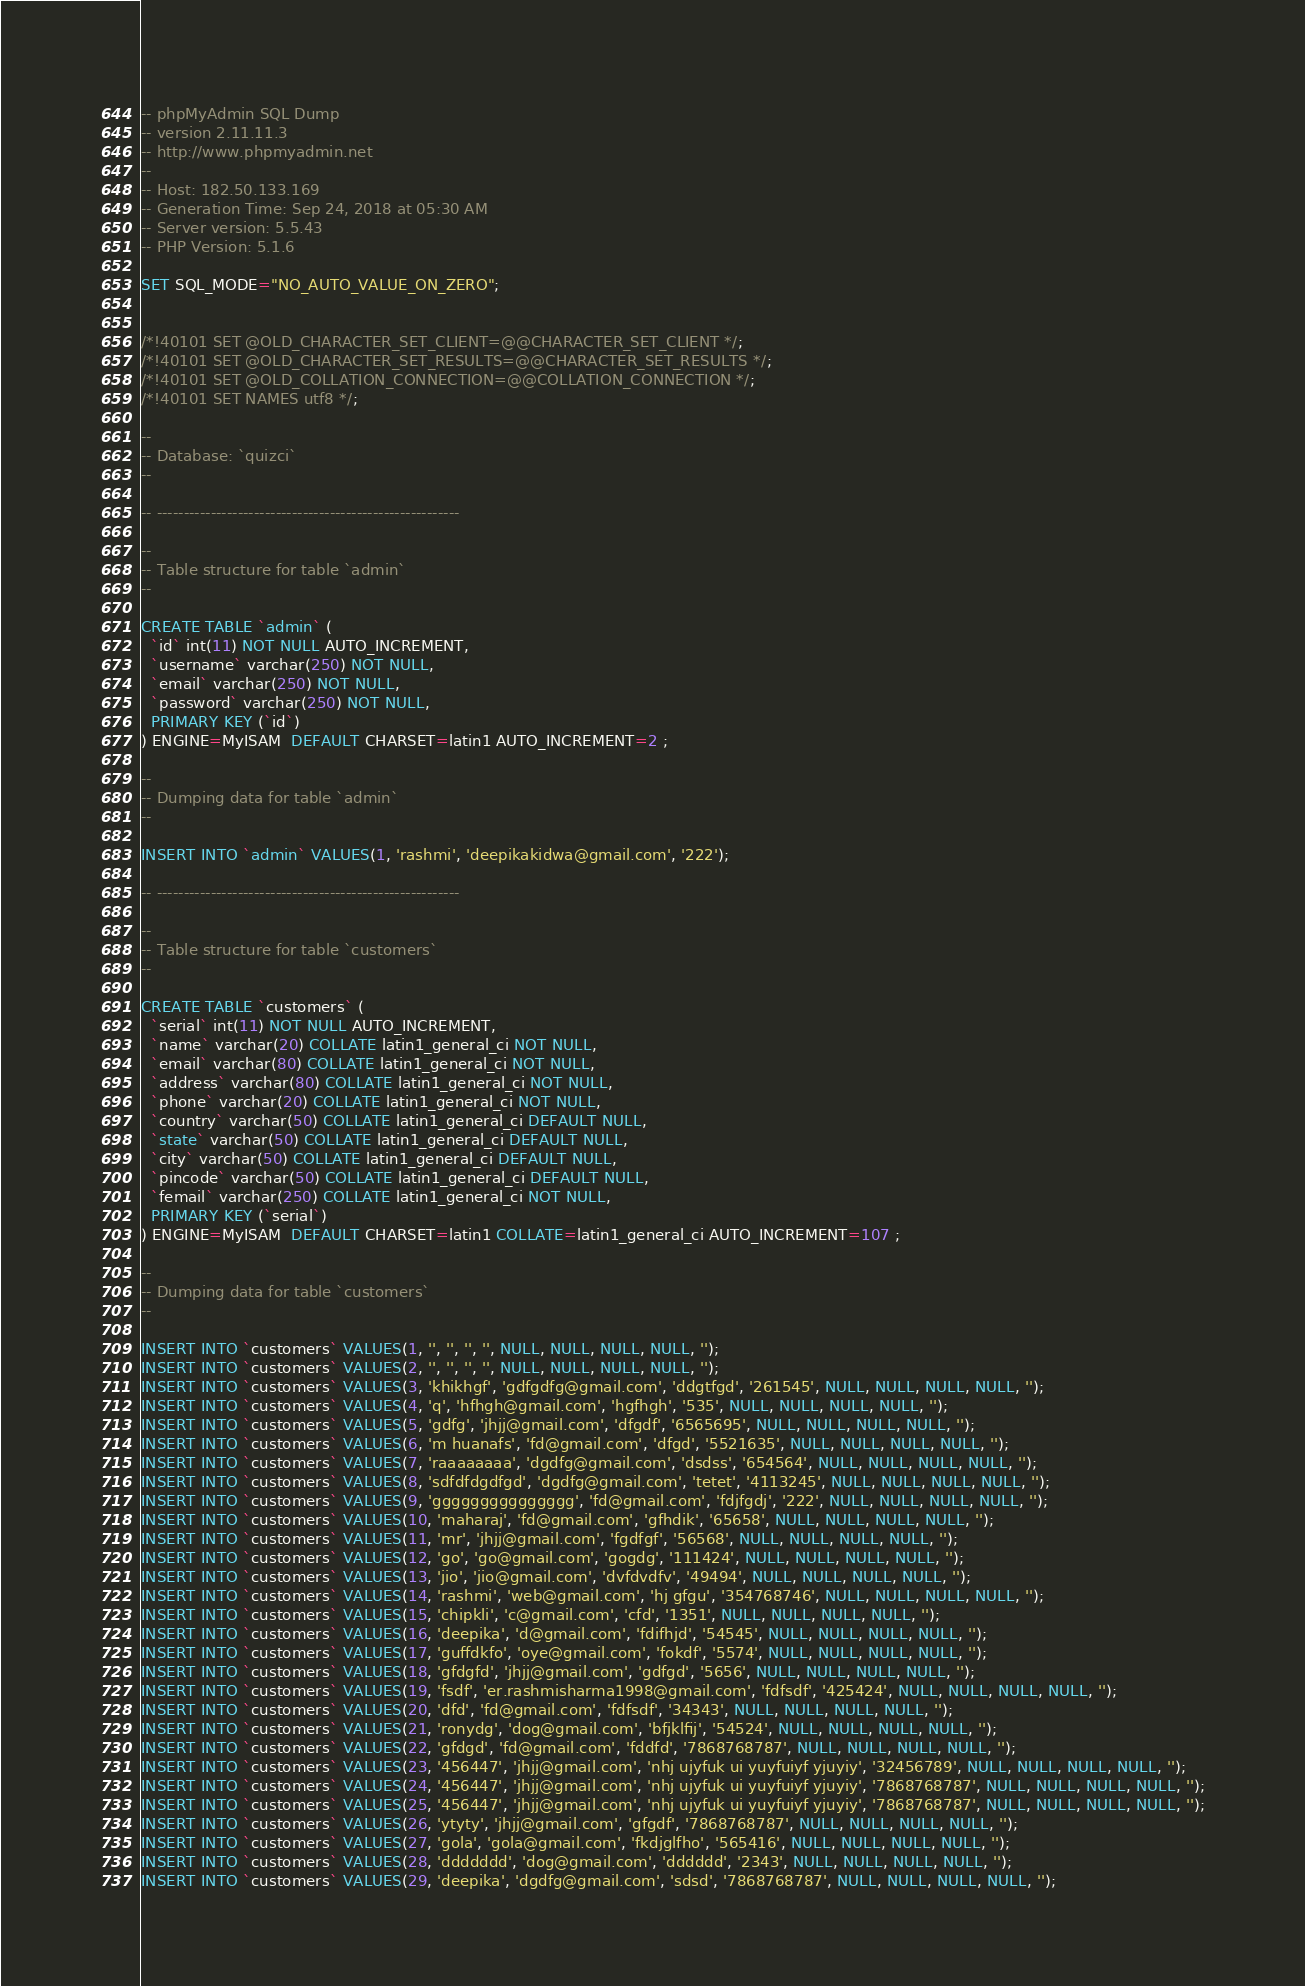Convert code to text. <code><loc_0><loc_0><loc_500><loc_500><_SQL_>-- phpMyAdmin SQL Dump
-- version 2.11.11.3
-- http://www.phpmyadmin.net
--
-- Host: 182.50.133.169
-- Generation Time: Sep 24, 2018 at 05:30 AM
-- Server version: 5.5.43
-- PHP Version: 5.1.6

SET SQL_MODE="NO_AUTO_VALUE_ON_ZERO";


/*!40101 SET @OLD_CHARACTER_SET_CLIENT=@@CHARACTER_SET_CLIENT */;
/*!40101 SET @OLD_CHARACTER_SET_RESULTS=@@CHARACTER_SET_RESULTS */;
/*!40101 SET @OLD_COLLATION_CONNECTION=@@COLLATION_CONNECTION */;
/*!40101 SET NAMES utf8 */;

--
-- Database: `quizci`
--

-- --------------------------------------------------------

--
-- Table structure for table `admin`
--

CREATE TABLE `admin` (
  `id` int(11) NOT NULL AUTO_INCREMENT,
  `username` varchar(250) NOT NULL,
  `email` varchar(250) NOT NULL,
  `password` varchar(250) NOT NULL,
  PRIMARY KEY (`id`)
) ENGINE=MyISAM  DEFAULT CHARSET=latin1 AUTO_INCREMENT=2 ;

--
-- Dumping data for table `admin`
--

INSERT INTO `admin` VALUES(1, 'rashmi', 'deepikakidwa@gmail.com', '222');

-- --------------------------------------------------------

--
-- Table structure for table `customers`
--

CREATE TABLE `customers` (
  `serial` int(11) NOT NULL AUTO_INCREMENT,
  `name` varchar(20) COLLATE latin1_general_ci NOT NULL,
  `email` varchar(80) COLLATE latin1_general_ci NOT NULL,
  `address` varchar(80) COLLATE latin1_general_ci NOT NULL,
  `phone` varchar(20) COLLATE latin1_general_ci NOT NULL,
  `country` varchar(50) COLLATE latin1_general_ci DEFAULT NULL,
  `state` varchar(50) COLLATE latin1_general_ci DEFAULT NULL,
  `city` varchar(50) COLLATE latin1_general_ci DEFAULT NULL,
  `pincode` varchar(50) COLLATE latin1_general_ci DEFAULT NULL,
  `femail` varchar(250) COLLATE latin1_general_ci NOT NULL,
  PRIMARY KEY (`serial`)
) ENGINE=MyISAM  DEFAULT CHARSET=latin1 COLLATE=latin1_general_ci AUTO_INCREMENT=107 ;

--
-- Dumping data for table `customers`
--

INSERT INTO `customers` VALUES(1, '', '', '', '', NULL, NULL, NULL, NULL, '');
INSERT INTO `customers` VALUES(2, '', '', '', '', NULL, NULL, NULL, NULL, '');
INSERT INTO `customers` VALUES(3, 'khikhgf', 'gdfgdfg@gmail.com', 'ddgtfgd', '261545', NULL, NULL, NULL, NULL, '');
INSERT INTO `customers` VALUES(4, 'q', 'hfhgh@gmail.com', 'hgfhgh', '535', NULL, NULL, NULL, NULL, '');
INSERT INTO `customers` VALUES(5, 'gdfg', 'jhjj@gmail.com', 'dfgdf', '6565695', NULL, NULL, NULL, NULL, '');
INSERT INTO `customers` VALUES(6, 'm huanafs', 'fd@gmail.com', 'dfgd', '5521635', NULL, NULL, NULL, NULL, '');
INSERT INTO `customers` VALUES(7, 'raaaaaaaa', 'dgdfg@gmail.com', 'dsdss', '654564', NULL, NULL, NULL, NULL, '');
INSERT INTO `customers` VALUES(8, 'sdfdfdgdfgd', 'dgdfg@gmail.com', 'tetet', '4113245', NULL, NULL, NULL, NULL, '');
INSERT INTO `customers` VALUES(9, 'ggggggggggggggg', 'fd@gmail.com', 'fdjfgdj', '222', NULL, NULL, NULL, NULL, '');
INSERT INTO `customers` VALUES(10, 'maharaj', 'fd@gmail.com', 'gfhdik', '65658', NULL, NULL, NULL, NULL, '');
INSERT INTO `customers` VALUES(11, 'mr', 'jhjj@gmail.com', 'fgdfgf', '56568', NULL, NULL, NULL, NULL, '');
INSERT INTO `customers` VALUES(12, 'go', 'go@gmail.com', 'gogdg', '111424', NULL, NULL, NULL, NULL, '');
INSERT INTO `customers` VALUES(13, 'jio', 'jio@gmail.com', 'dvfdvdfv', '49494', NULL, NULL, NULL, NULL, '');
INSERT INTO `customers` VALUES(14, 'rashmi', 'web@gmail.com', 'hj gfgu', '354768746', NULL, NULL, NULL, NULL, '');
INSERT INTO `customers` VALUES(15, 'chipkli', 'c@gmail.com', 'cfd', '1351', NULL, NULL, NULL, NULL, '');
INSERT INTO `customers` VALUES(16, 'deepika', 'd@gmail.com', 'fdifhjd', '54545', NULL, NULL, NULL, NULL, '');
INSERT INTO `customers` VALUES(17, 'guffdkfo', 'oye@gmail.com', 'fokdf', '5574', NULL, NULL, NULL, NULL, '');
INSERT INTO `customers` VALUES(18, 'gfdgfd', 'jhjj@gmail.com', 'gdfgd', '5656', NULL, NULL, NULL, NULL, '');
INSERT INTO `customers` VALUES(19, 'fsdf', 'er.rashmisharma1998@gmail.com', 'fdfsdf', '425424', NULL, NULL, NULL, NULL, '');
INSERT INTO `customers` VALUES(20, 'dfd', 'fd@gmail.com', 'fdfsdf', '34343', NULL, NULL, NULL, NULL, '');
INSERT INTO `customers` VALUES(21, 'ronydg', 'dog@gmail.com', 'bfjklfij', '54524', NULL, NULL, NULL, NULL, '');
INSERT INTO `customers` VALUES(22, 'gfdgd', 'fd@gmail.com', 'fddfd', '7868768787', NULL, NULL, NULL, NULL, '');
INSERT INTO `customers` VALUES(23, '456447', 'jhjj@gmail.com', 'nhj ujyfuk ui yuyfuiyf yjuyiy', '32456789', NULL, NULL, NULL, NULL, '');
INSERT INTO `customers` VALUES(24, '456447', 'jhjj@gmail.com', 'nhj ujyfuk ui yuyfuiyf yjuyiy', '7868768787', NULL, NULL, NULL, NULL, '');
INSERT INTO `customers` VALUES(25, '456447', 'jhjj@gmail.com', 'nhj ujyfuk ui yuyfuiyf yjuyiy', '7868768787', NULL, NULL, NULL, NULL, '');
INSERT INTO `customers` VALUES(26, 'ytyty', 'jhjj@gmail.com', 'gfgdf', '7868768787', NULL, NULL, NULL, NULL, '');
INSERT INTO `customers` VALUES(27, 'gola', 'gola@gmail.com', 'fkdjglfho', '565416', NULL, NULL, NULL, NULL, '');
INSERT INTO `customers` VALUES(28, 'ddddddd', 'dog@gmail.com', 'dddddd', '2343', NULL, NULL, NULL, NULL, '');
INSERT INTO `customers` VALUES(29, 'deepika', 'dgdfg@gmail.com', 'sdsd', '7868768787', NULL, NULL, NULL, NULL, '');</code> 